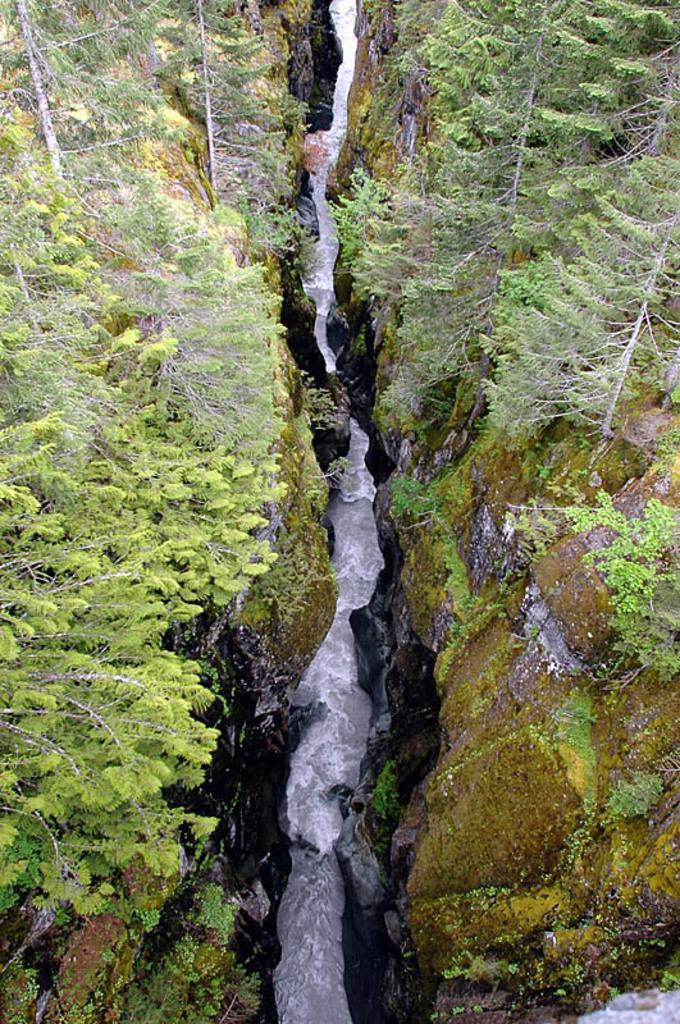Where was the picture taken? The picture was taken outside. What is the main feature in the center of the image? There is a water-like feature in the center of the image. What can be seen on both sides of the water-like feature? There are rocks and plants on both sides of the water-like feature. Are there any other items visible on both sides of the water-like feature? Yes, there are other unspecified items on both sides of the water-like feature. What type of feeling does the island in the image evoke? There is no island present in the image, so it is not possible to determine the feeling it might evoke. 